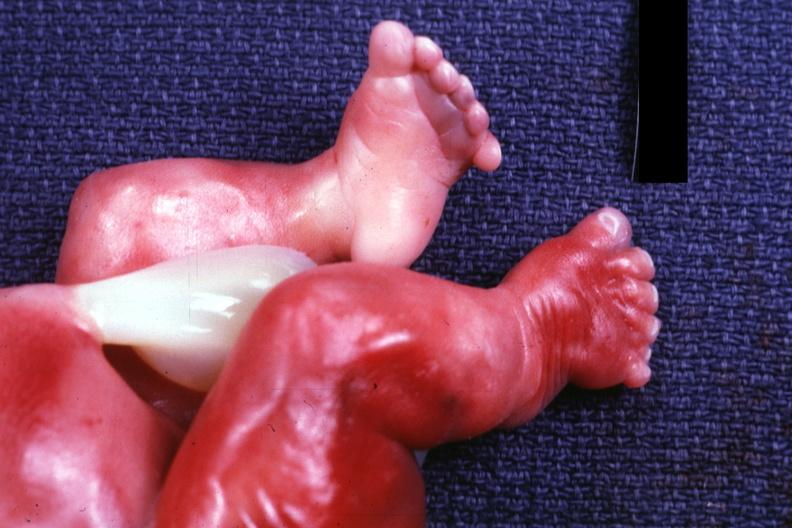re extremities present?
Answer the question using a single word or phrase. Yes 